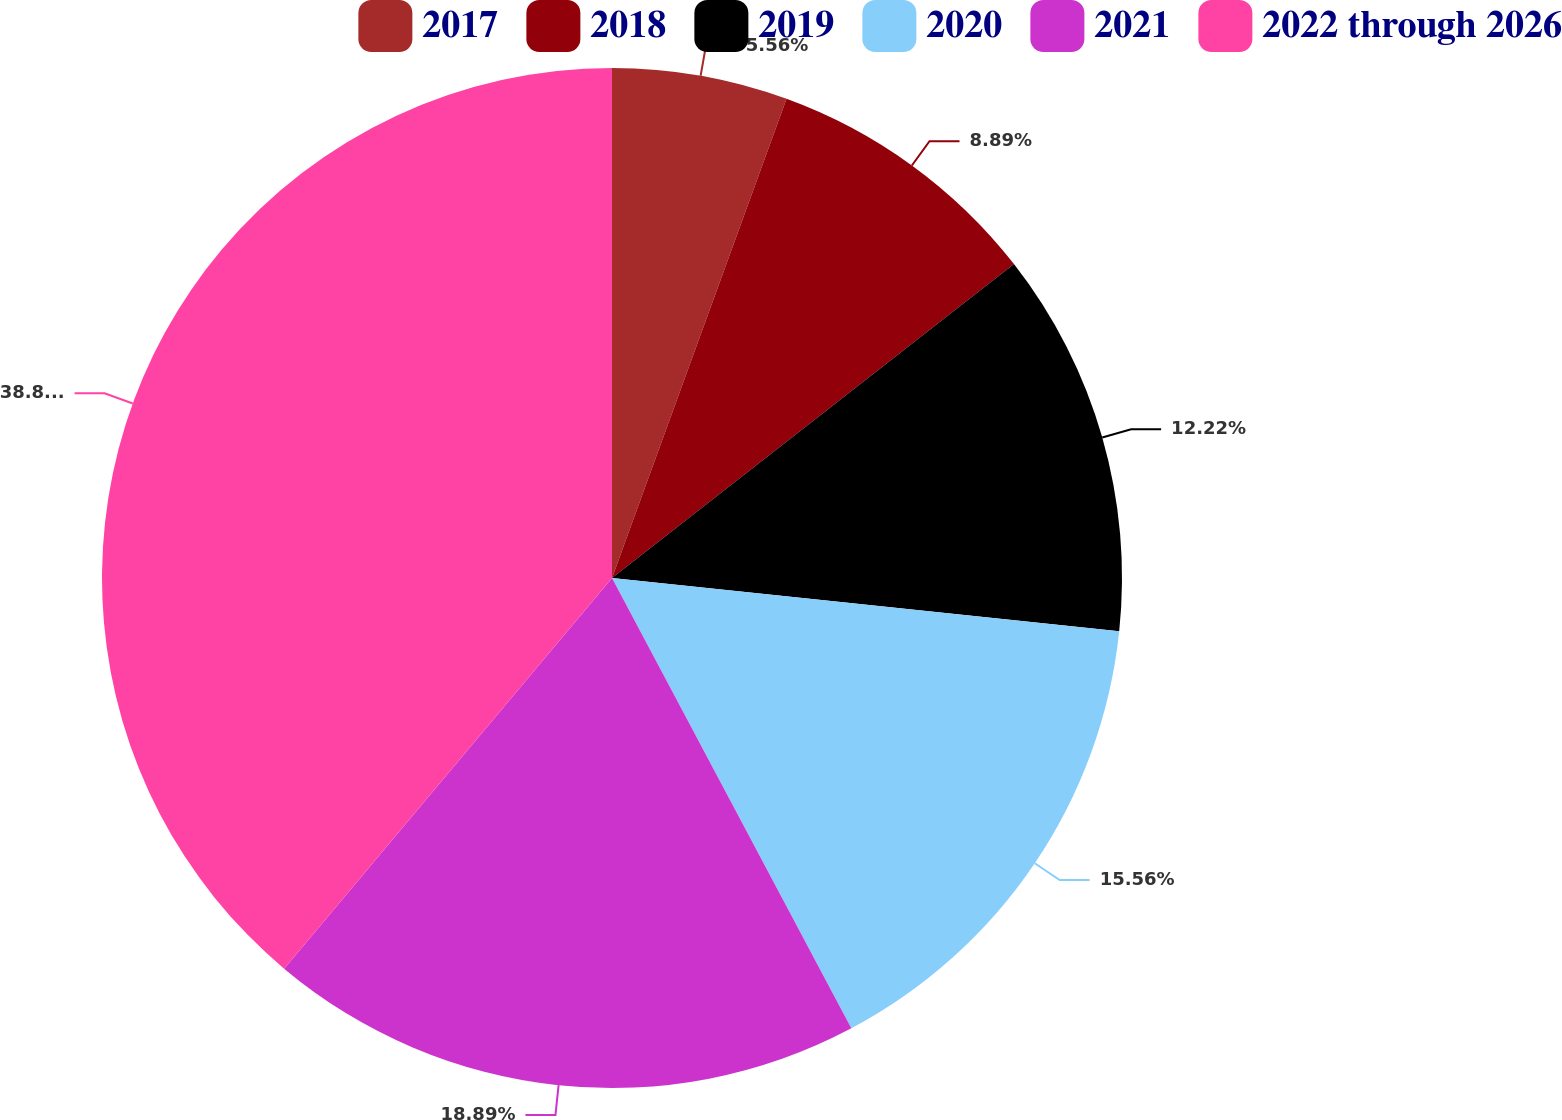<chart> <loc_0><loc_0><loc_500><loc_500><pie_chart><fcel>2017<fcel>2018<fcel>2019<fcel>2020<fcel>2021<fcel>2022 through 2026<nl><fcel>5.56%<fcel>8.89%<fcel>12.22%<fcel>15.56%<fcel>18.89%<fcel>38.89%<nl></chart> 